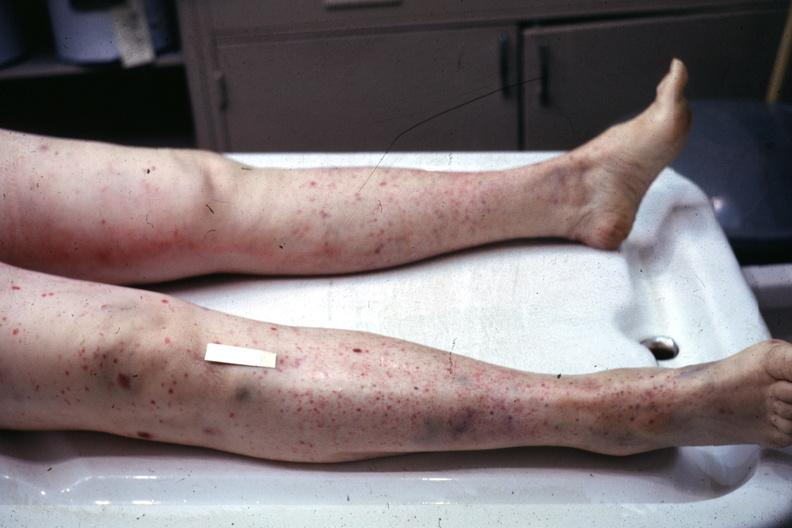s leg present?
Answer the question using a single word or phrase. Yes 